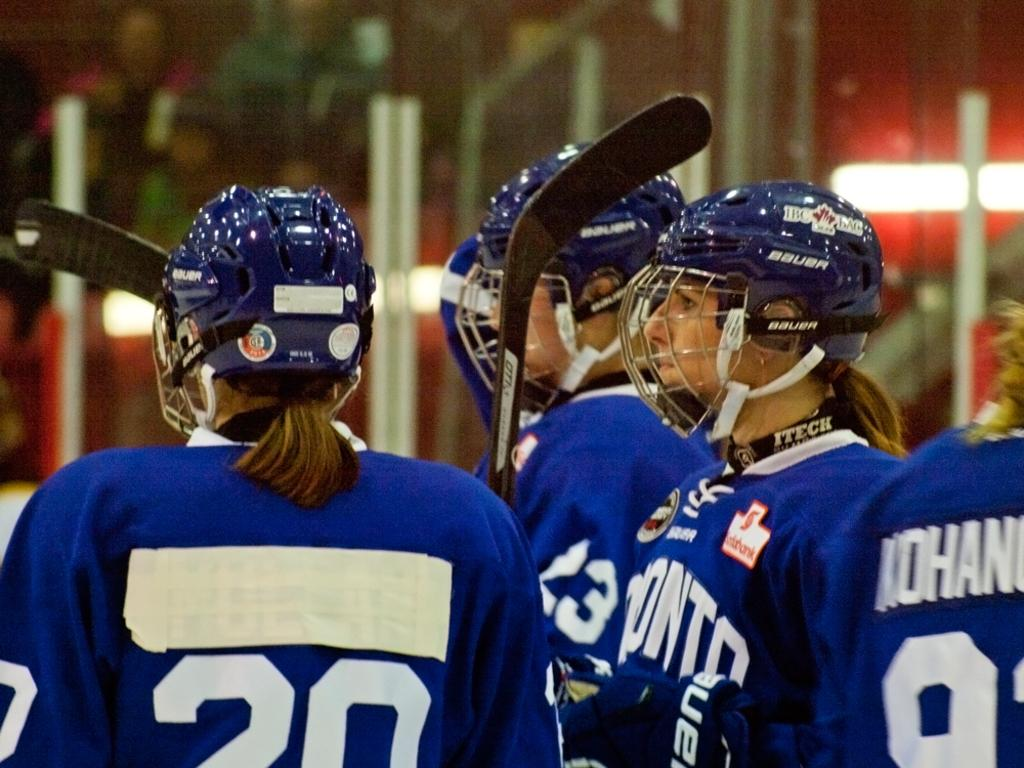What are the persons in the image wearing on their heads? The persons in the image are wearing helmets. What are the persons holding in their hands? Some of the persons are holding sticks. What can be seen in the background of the image? There are trees in the background of the image. How would you describe the appearance of the background? The background appears blurry. How many jellyfish can be seen floating in the air in the image? There are no jellyfish present in the image; it features persons wearing helmets and holding sticks, with trees in the background. 